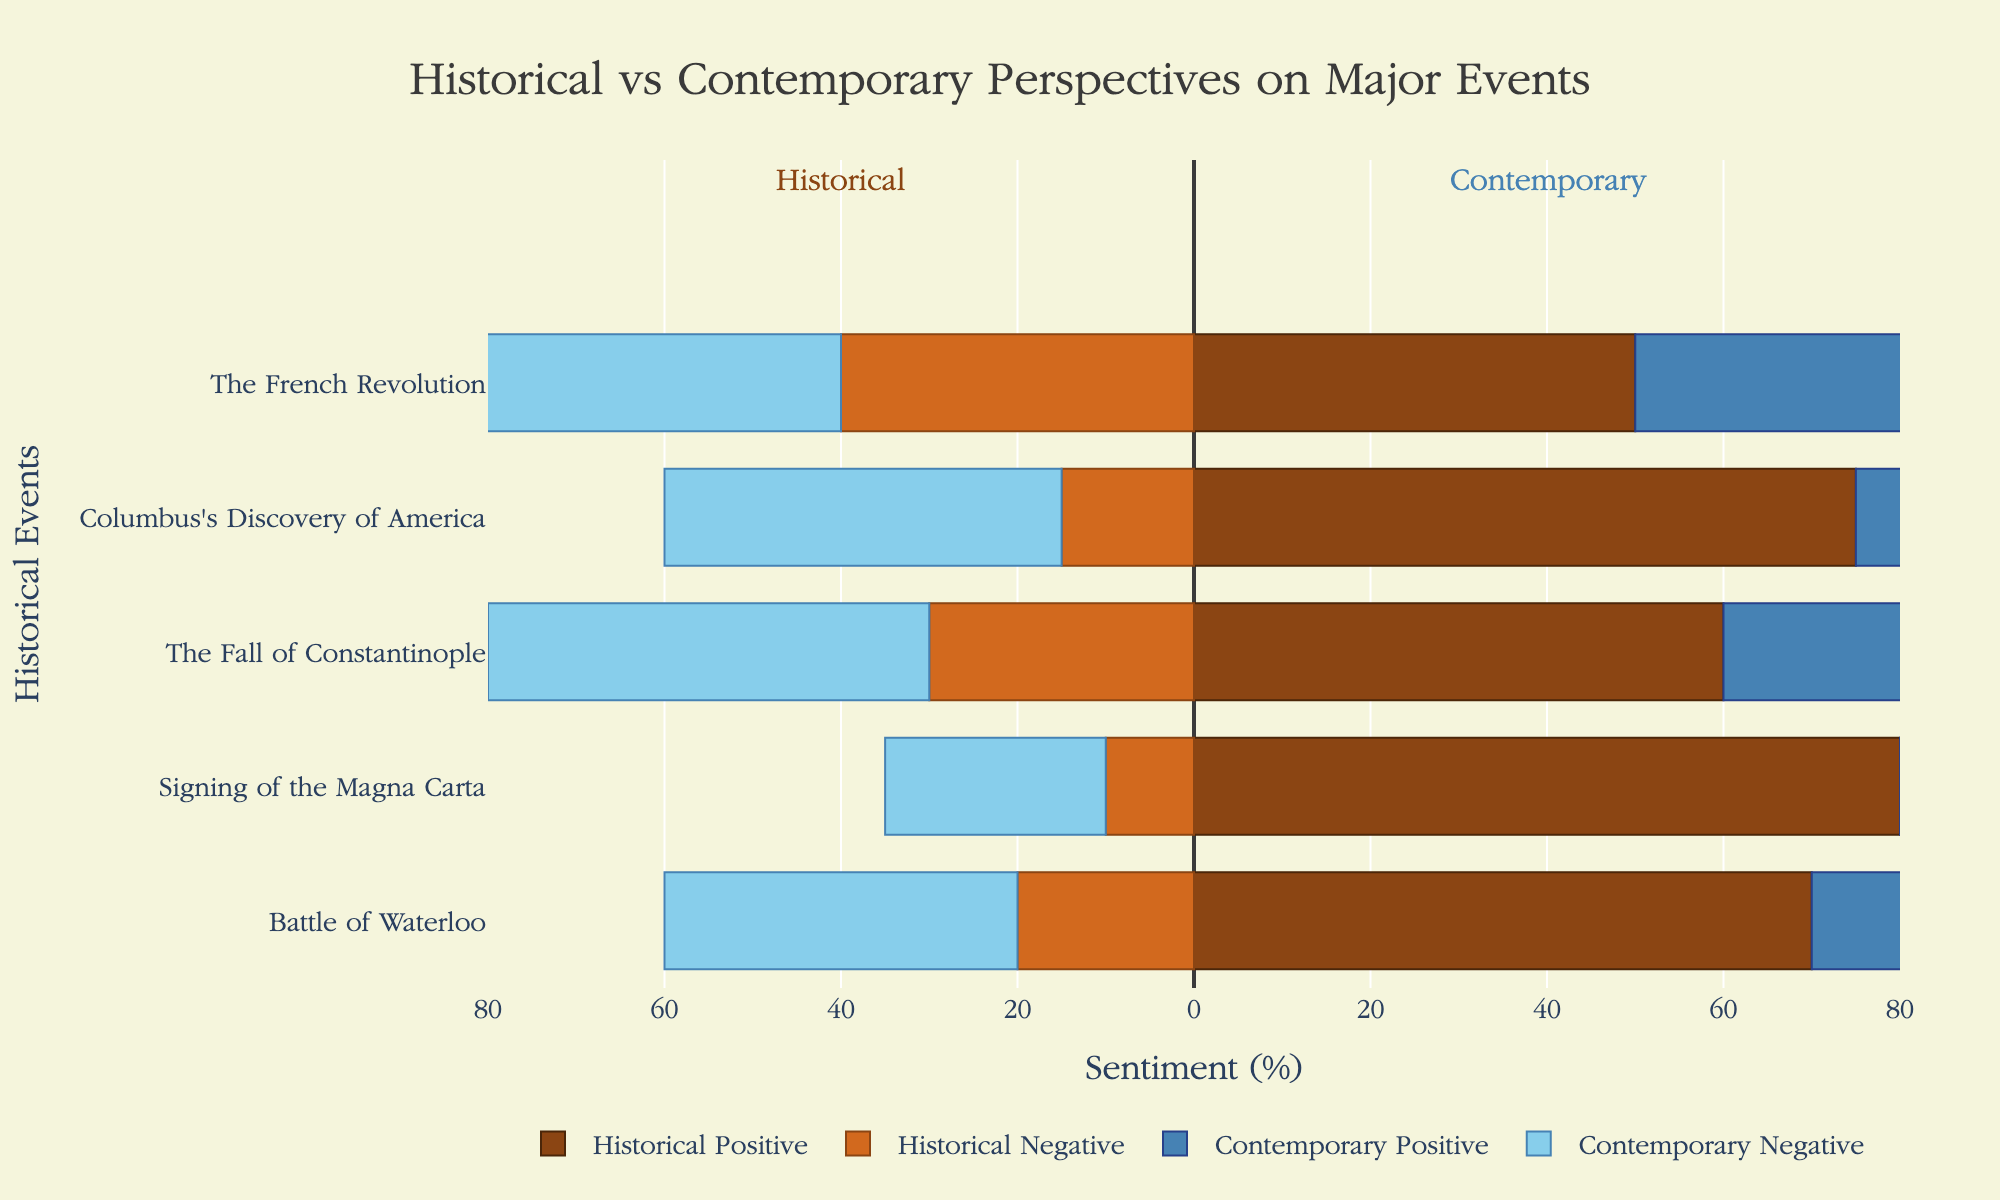Which event has the largest difference in negative sentiment between historical and contemporary accounts? To determine the event with the largest difference in negative sentiment, we compare the differences between historical and contemporary negative sentiments for all events. Here are the differences: Battle of Waterloo (40-20=20), Signing of the Magna Carta (25-10=15), The Fall of Constantinople (50-30=20), Columbus's Discovery of America (45-15=30), The French Revolution (55-40=15). Therefore, the largest difference is for Columbus's Discovery of America.
Answer: Columbus's Discovery of America Which account type shows more positive sentiment for the Battle of Waterloo? To answer this, we compare the positive sentiment values for historical and contemporary accounts for the Battle of Waterloo. The historical account has a positive sentiment of 70%, whereas the contemporary account has a positive sentiment of 50%. Therefore, the historical account shows more positive sentiment.
Answer: Historical account What is the average negative sentiment for contemporary accounts? To find the average negative sentiment for contemporary accounts, we sum the negative sentiments for contemporary accounts and divide by the number of events. The sum is 40 + 25 + 50 + 45 + 55 = 215. There are 5 events, so the average is 215 / 5 = 43%.
Answer: 43% How does the negative sentiment for contemporary accounts of the Fall of Constantinople compare to the negative sentiment for historical accounts? We compare the negative sentiment values: contemporary (50%) and historical (30%). The negative sentiment for contemporary accounts is higher than that for historical accounts by 20%.
Answer: The negative sentiment for contemporary accounts is higher by 20% Are the neutral sentiments different between historical and contemporary accounts for the French Revolution? We compare the neutral sentiment percentages. Both historical and contemporary accounts for the French Revolution show 10% neutral sentiment. Therefore, the neutral sentiments are not different; they are the same.
Answer: No, they are the same Which account type has a higher positive sentiment for the Signing of the Magna Carta? By comparing positive sentiments, we see that the historical account has 80% positive sentiment, whereas the contemporary account has 65%. Therefore, the historical account has a higher positive sentiment.
Answer: Historical account Is there any event where contemporary accounts show greater positive sentiment than historical accounts? We need to check if the positive sentiment for contemporary accounts is higher than for historical accounts for any of the events. We see that for each event (Battle of Waterloo, Signing of the Magna Carta, The Fall of Constantinople, Columbus's Discovery of America, The French Revolution), the historical accounts always have higher positive sentiment. Therefore, there is no event where contemporary accounts show greater positive sentiment.
Answer: No, there isn't Which event has the smallest difference in positive sentiment between historical and contemporary accounts? We determine the differences between historical and contemporary positive sentiments: Battle of Waterloo (70-50=20), Signing of the Magna Carta (80-65=15), The Fall of Constantinople (60-40=20), Columbus's Discovery of America (75-45=30), The French Revolution (50-35=15). Both the Signing of the Magna Carta and The French Revolution have the smallest difference of 15.
Answer: Signing of the Magna Carta and The French Revolution 